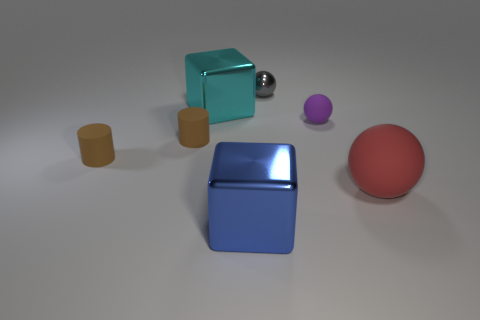How many purple matte objects are in front of the big cyan metallic cube?
Provide a succinct answer. 1. Is there a tiny brown cylinder made of the same material as the purple object?
Provide a short and direct response. Yes. What material is the red object that is the same size as the blue object?
Keep it short and to the point. Rubber. Is the small purple ball made of the same material as the big red sphere?
Make the answer very short. Yes. What number of things are either blocks or tiny gray spheres?
Your answer should be compact. 3. What shape is the shiny object in front of the big red rubber thing?
Offer a very short reply. Cube. What color is the sphere that is made of the same material as the cyan object?
Your answer should be very brief. Gray. What is the material of the tiny purple thing that is the same shape as the big rubber thing?
Provide a short and direct response. Rubber. What shape is the blue metallic object?
Provide a succinct answer. Cube. What is the material of the thing that is both in front of the gray metallic thing and behind the small purple rubber sphere?
Keep it short and to the point. Metal. 